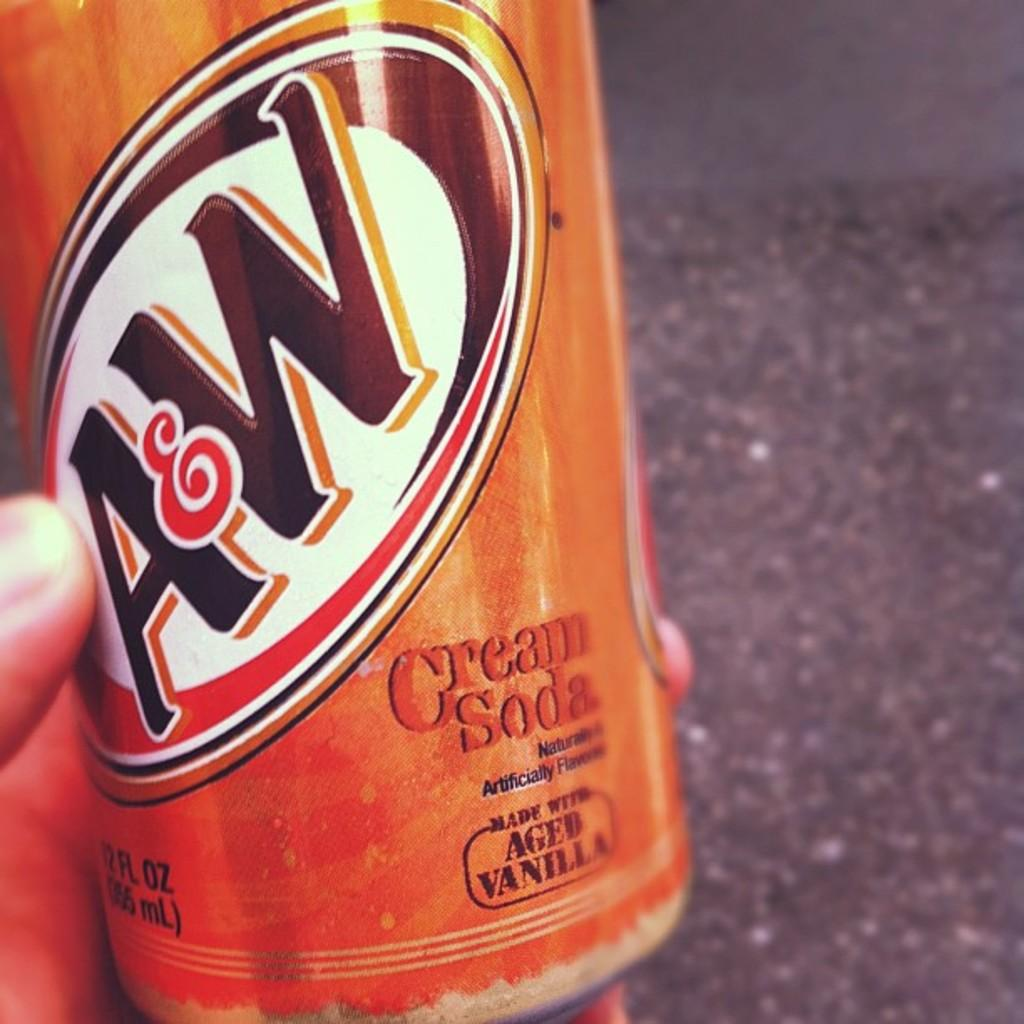What is the hand in the image holding? The hand is holding a bottle. Can you describe the bottle in the image? The bottle is truncated. What color is present on the right side of the image? There is grey color on the right side of the image. What type of celery is being harvested by the mother in the image? There is no mother or celery present in the image; it only features a hand holding a truncated bottle. 